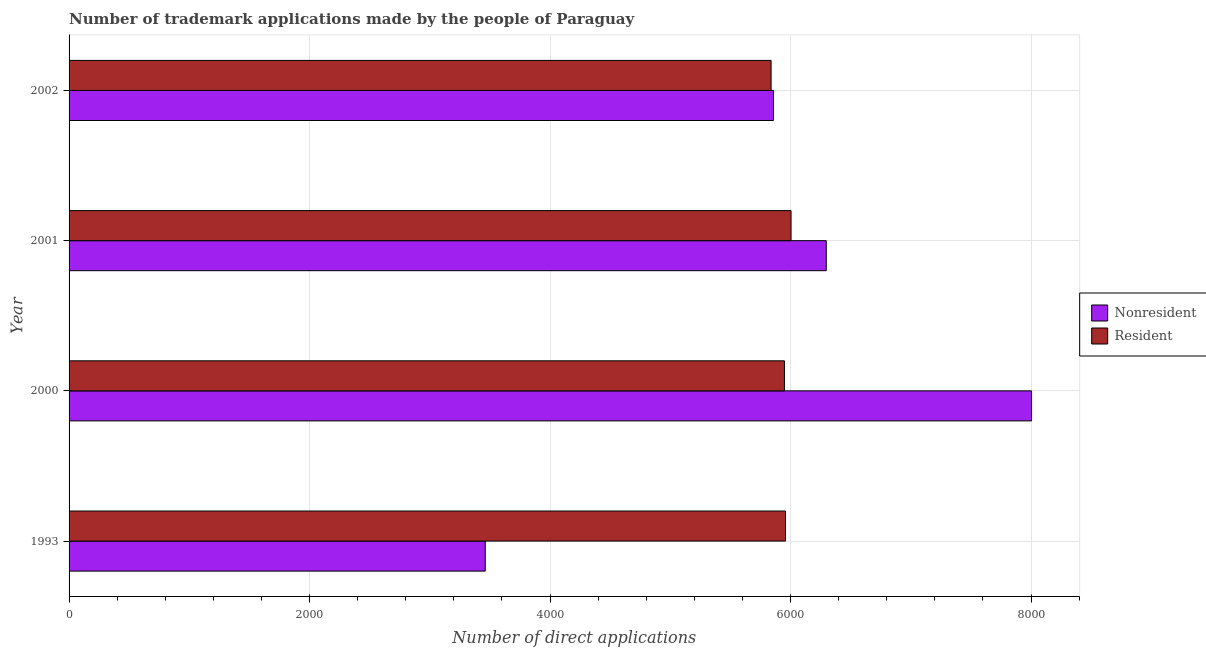How many different coloured bars are there?
Keep it short and to the point. 2. How many groups of bars are there?
Offer a terse response. 4. Are the number of bars on each tick of the Y-axis equal?
Make the answer very short. Yes. How many bars are there on the 4th tick from the top?
Give a very brief answer. 2. How many bars are there on the 4th tick from the bottom?
Keep it short and to the point. 2. What is the number of trademark applications made by residents in 2001?
Offer a terse response. 6004. Across all years, what is the maximum number of trademark applications made by non residents?
Ensure brevity in your answer.  8004. Across all years, what is the minimum number of trademark applications made by residents?
Keep it short and to the point. 5838. What is the total number of trademark applications made by residents in the graph?
Your response must be concise. 2.37e+04. What is the difference between the number of trademark applications made by non residents in 2000 and that in 2002?
Provide a succinct answer. 2146. What is the difference between the number of trademark applications made by residents in 2001 and the number of trademark applications made by non residents in 1993?
Your answer should be compact. 2543. What is the average number of trademark applications made by residents per year?
Give a very brief answer. 5937.25. In the year 2002, what is the difference between the number of trademark applications made by residents and number of trademark applications made by non residents?
Ensure brevity in your answer.  -20. In how many years, is the number of trademark applications made by residents greater than 6000 ?
Your answer should be very brief. 1. What is the ratio of the number of trademark applications made by non residents in 2000 to that in 2002?
Your answer should be very brief. 1.37. What is the difference between the highest and the second highest number of trademark applications made by non residents?
Provide a succinct answer. 1707. What is the difference between the highest and the lowest number of trademark applications made by non residents?
Your answer should be compact. 4543. Is the sum of the number of trademark applications made by residents in 2000 and 2001 greater than the maximum number of trademark applications made by non residents across all years?
Make the answer very short. Yes. What does the 1st bar from the top in 2002 represents?
Give a very brief answer. Resident. What does the 2nd bar from the bottom in 2001 represents?
Offer a very short reply. Resident. Are all the bars in the graph horizontal?
Offer a very short reply. Yes. How many years are there in the graph?
Ensure brevity in your answer.  4. What is the difference between two consecutive major ticks on the X-axis?
Provide a short and direct response. 2000. Are the values on the major ticks of X-axis written in scientific E-notation?
Ensure brevity in your answer.  No. Does the graph contain grids?
Your answer should be very brief. Yes. Where does the legend appear in the graph?
Provide a succinct answer. Center right. How many legend labels are there?
Keep it short and to the point. 2. How are the legend labels stacked?
Your response must be concise. Vertical. What is the title of the graph?
Your answer should be very brief. Number of trademark applications made by the people of Paraguay. What is the label or title of the X-axis?
Ensure brevity in your answer.  Number of direct applications. What is the Number of direct applications of Nonresident in 1993?
Your answer should be very brief. 3461. What is the Number of direct applications in Resident in 1993?
Offer a very short reply. 5958. What is the Number of direct applications in Nonresident in 2000?
Your response must be concise. 8004. What is the Number of direct applications in Resident in 2000?
Your answer should be very brief. 5949. What is the Number of direct applications of Nonresident in 2001?
Provide a short and direct response. 6297. What is the Number of direct applications in Resident in 2001?
Provide a succinct answer. 6004. What is the Number of direct applications in Nonresident in 2002?
Keep it short and to the point. 5858. What is the Number of direct applications of Resident in 2002?
Give a very brief answer. 5838. Across all years, what is the maximum Number of direct applications of Nonresident?
Provide a succinct answer. 8004. Across all years, what is the maximum Number of direct applications of Resident?
Your response must be concise. 6004. Across all years, what is the minimum Number of direct applications in Nonresident?
Offer a very short reply. 3461. Across all years, what is the minimum Number of direct applications of Resident?
Offer a terse response. 5838. What is the total Number of direct applications in Nonresident in the graph?
Your answer should be compact. 2.36e+04. What is the total Number of direct applications in Resident in the graph?
Give a very brief answer. 2.37e+04. What is the difference between the Number of direct applications of Nonresident in 1993 and that in 2000?
Keep it short and to the point. -4543. What is the difference between the Number of direct applications in Nonresident in 1993 and that in 2001?
Ensure brevity in your answer.  -2836. What is the difference between the Number of direct applications in Resident in 1993 and that in 2001?
Offer a very short reply. -46. What is the difference between the Number of direct applications of Nonresident in 1993 and that in 2002?
Keep it short and to the point. -2397. What is the difference between the Number of direct applications in Resident in 1993 and that in 2002?
Ensure brevity in your answer.  120. What is the difference between the Number of direct applications in Nonresident in 2000 and that in 2001?
Your response must be concise. 1707. What is the difference between the Number of direct applications in Resident in 2000 and that in 2001?
Provide a succinct answer. -55. What is the difference between the Number of direct applications of Nonresident in 2000 and that in 2002?
Your answer should be very brief. 2146. What is the difference between the Number of direct applications in Resident in 2000 and that in 2002?
Your answer should be compact. 111. What is the difference between the Number of direct applications of Nonresident in 2001 and that in 2002?
Your response must be concise. 439. What is the difference between the Number of direct applications in Resident in 2001 and that in 2002?
Offer a very short reply. 166. What is the difference between the Number of direct applications of Nonresident in 1993 and the Number of direct applications of Resident in 2000?
Give a very brief answer. -2488. What is the difference between the Number of direct applications of Nonresident in 1993 and the Number of direct applications of Resident in 2001?
Give a very brief answer. -2543. What is the difference between the Number of direct applications of Nonresident in 1993 and the Number of direct applications of Resident in 2002?
Offer a very short reply. -2377. What is the difference between the Number of direct applications of Nonresident in 2000 and the Number of direct applications of Resident in 2001?
Your answer should be very brief. 2000. What is the difference between the Number of direct applications in Nonresident in 2000 and the Number of direct applications in Resident in 2002?
Make the answer very short. 2166. What is the difference between the Number of direct applications in Nonresident in 2001 and the Number of direct applications in Resident in 2002?
Give a very brief answer. 459. What is the average Number of direct applications of Nonresident per year?
Your answer should be very brief. 5905. What is the average Number of direct applications in Resident per year?
Ensure brevity in your answer.  5937.25. In the year 1993, what is the difference between the Number of direct applications in Nonresident and Number of direct applications in Resident?
Provide a succinct answer. -2497. In the year 2000, what is the difference between the Number of direct applications in Nonresident and Number of direct applications in Resident?
Offer a terse response. 2055. In the year 2001, what is the difference between the Number of direct applications in Nonresident and Number of direct applications in Resident?
Make the answer very short. 293. In the year 2002, what is the difference between the Number of direct applications of Nonresident and Number of direct applications of Resident?
Provide a succinct answer. 20. What is the ratio of the Number of direct applications of Nonresident in 1993 to that in 2000?
Provide a short and direct response. 0.43. What is the ratio of the Number of direct applications of Nonresident in 1993 to that in 2001?
Provide a succinct answer. 0.55. What is the ratio of the Number of direct applications of Nonresident in 1993 to that in 2002?
Make the answer very short. 0.59. What is the ratio of the Number of direct applications of Resident in 1993 to that in 2002?
Your answer should be compact. 1.02. What is the ratio of the Number of direct applications of Nonresident in 2000 to that in 2001?
Ensure brevity in your answer.  1.27. What is the ratio of the Number of direct applications of Nonresident in 2000 to that in 2002?
Provide a succinct answer. 1.37. What is the ratio of the Number of direct applications in Resident in 2000 to that in 2002?
Provide a succinct answer. 1.02. What is the ratio of the Number of direct applications of Nonresident in 2001 to that in 2002?
Ensure brevity in your answer.  1.07. What is the ratio of the Number of direct applications of Resident in 2001 to that in 2002?
Offer a terse response. 1.03. What is the difference between the highest and the second highest Number of direct applications of Nonresident?
Your response must be concise. 1707. What is the difference between the highest and the second highest Number of direct applications of Resident?
Offer a terse response. 46. What is the difference between the highest and the lowest Number of direct applications in Nonresident?
Offer a very short reply. 4543. What is the difference between the highest and the lowest Number of direct applications in Resident?
Your answer should be compact. 166. 